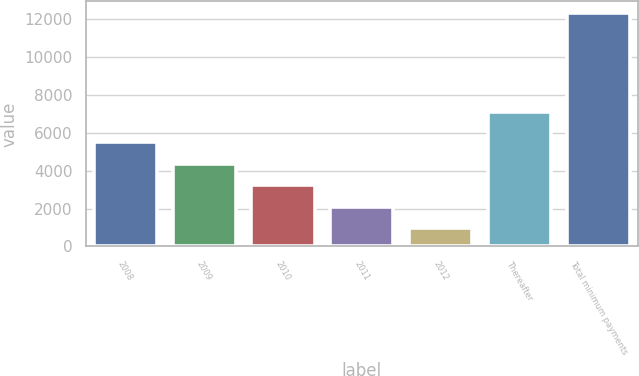Convert chart. <chart><loc_0><loc_0><loc_500><loc_500><bar_chart><fcel>2008<fcel>2009<fcel>2010<fcel>2011<fcel>2012<fcel>Thereafter<fcel>Total minimum payments<nl><fcel>5504.46<fcel>4368.17<fcel>3231.88<fcel>2095.59<fcel>959.3<fcel>7117.7<fcel>12322.2<nl></chart> 